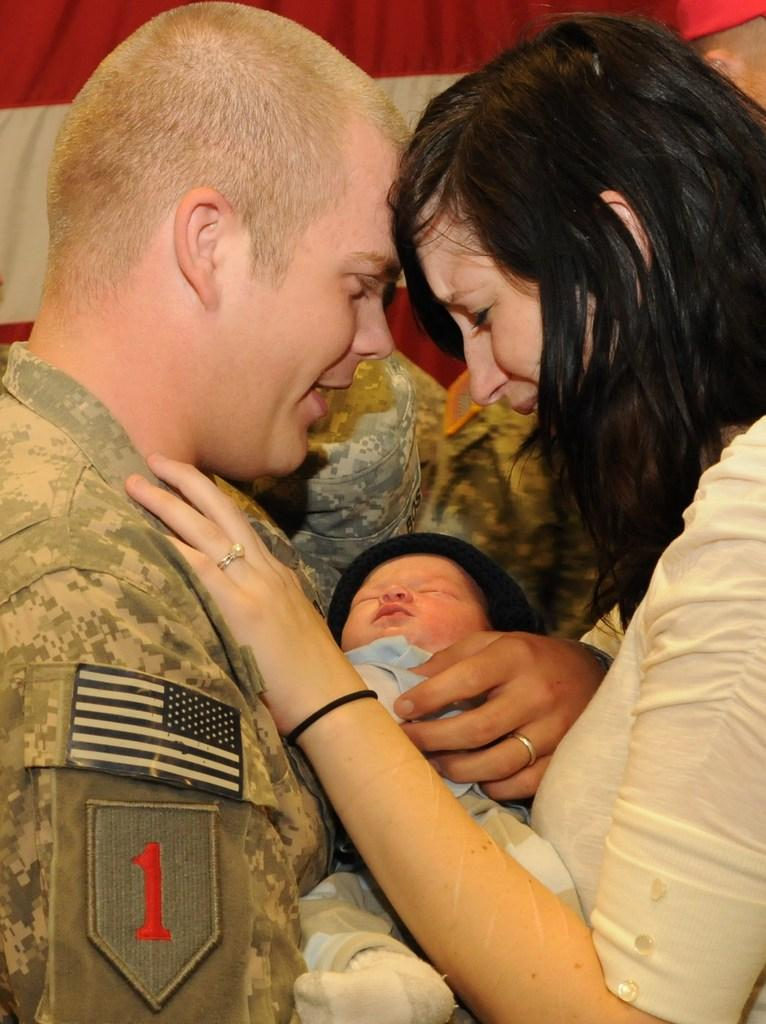Who is present in the picture? There is a couple in the picture. Where are the couple located in the image? The couple is in the middle of the picture. What is between the couple? There is a baby between the couple. How many trees can be seen in the picture? There are no trees visible in the picture; it features a couple with a baby between them. What type of stretch is the couple performing in the image? There is no stretch being performed in the image; the couple is simply standing together with a baby between them. 